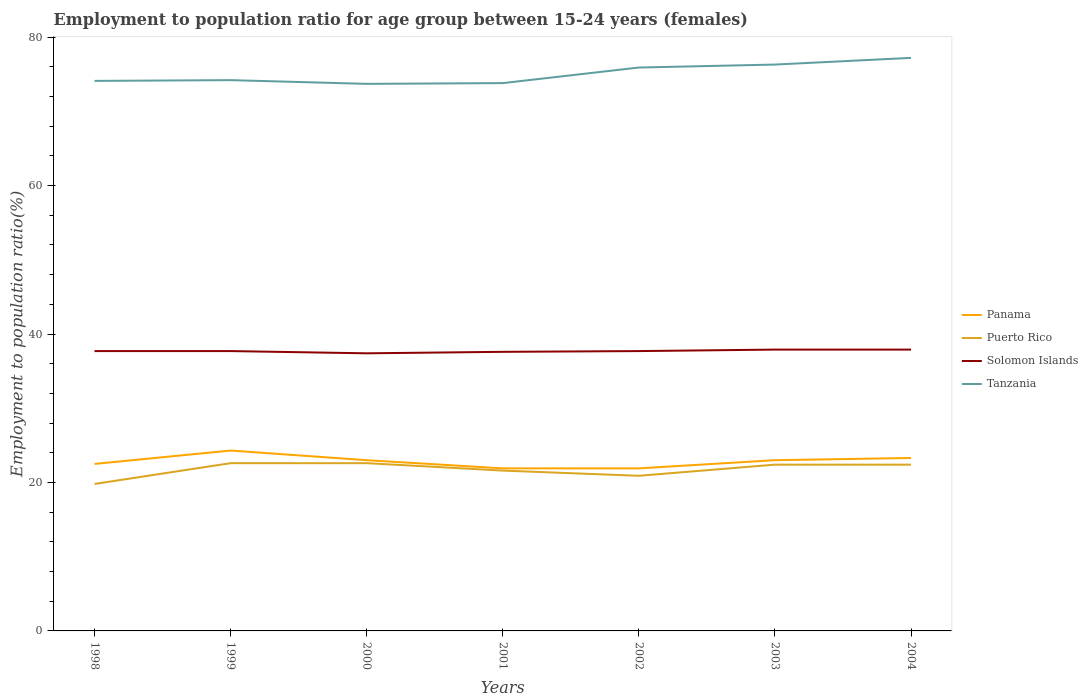Is the number of lines equal to the number of legend labels?
Ensure brevity in your answer.  Yes. Across all years, what is the maximum employment to population ratio in Panama?
Ensure brevity in your answer.  21.9. In which year was the employment to population ratio in Panama maximum?
Make the answer very short. 2001. What is the total employment to population ratio in Tanzania in the graph?
Your response must be concise. 0.4. What is the difference between the highest and the second highest employment to population ratio in Puerto Rico?
Offer a terse response. 2.8. What is the difference between the highest and the lowest employment to population ratio in Tanzania?
Provide a succinct answer. 3. Is the employment to population ratio in Panama strictly greater than the employment to population ratio in Solomon Islands over the years?
Your response must be concise. Yes. How many lines are there?
Make the answer very short. 4. How many years are there in the graph?
Offer a very short reply. 7. What is the difference between two consecutive major ticks on the Y-axis?
Make the answer very short. 20. Does the graph contain any zero values?
Provide a short and direct response. No. Does the graph contain grids?
Provide a succinct answer. No. Where does the legend appear in the graph?
Offer a terse response. Center right. How many legend labels are there?
Give a very brief answer. 4. What is the title of the graph?
Make the answer very short. Employment to population ratio for age group between 15-24 years (females). What is the Employment to population ratio(%) of Panama in 1998?
Your answer should be very brief. 22.5. What is the Employment to population ratio(%) of Puerto Rico in 1998?
Your answer should be very brief. 19.8. What is the Employment to population ratio(%) in Solomon Islands in 1998?
Your answer should be very brief. 37.7. What is the Employment to population ratio(%) of Tanzania in 1998?
Provide a succinct answer. 74.1. What is the Employment to population ratio(%) in Panama in 1999?
Your response must be concise. 24.3. What is the Employment to population ratio(%) in Puerto Rico in 1999?
Keep it short and to the point. 22.6. What is the Employment to population ratio(%) in Solomon Islands in 1999?
Keep it short and to the point. 37.7. What is the Employment to population ratio(%) in Tanzania in 1999?
Your response must be concise. 74.2. What is the Employment to population ratio(%) of Puerto Rico in 2000?
Keep it short and to the point. 22.6. What is the Employment to population ratio(%) of Solomon Islands in 2000?
Ensure brevity in your answer.  37.4. What is the Employment to population ratio(%) of Tanzania in 2000?
Ensure brevity in your answer.  73.7. What is the Employment to population ratio(%) of Panama in 2001?
Your response must be concise. 21.9. What is the Employment to population ratio(%) in Puerto Rico in 2001?
Provide a short and direct response. 21.6. What is the Employment to population ratio(%) of Solomon Islands in 2001?
Your answer should be very brief. 37.6. What is the Employment to population ratio(%) in Tanzania in 2001?
Provide a succinct answer. 73.8. What is the Employment to population ratio(%) of Panama in 2002?
Offer a very short reply. 21.9. What is the Employment to population ratio(%) in Puerto Rico in 2002?
Offer a very short reply. 20.9. What is the Employment to population ratio(%) in Solomon Islands in 2002?
Ensure brevity in your answer.  37.7. What is the Employment to population ratio(%) in Tanzania in 2002?
Give a very brief answer. 75.9. What is the Employment to population ratio(%) in Panama in 2003?
Your answer should be compact. 23. What is the Employment to population ratio(%) in Puerto Rico in 2003?
Give a very brief answer. 22.4. What is the Employment to population ratio(%) in Solomon Islands in 2003?
Provide a short and direct response. 37.9. What is the Employment to population ratio(%) in Tanzania in 2003?
Your answer should be compact. 76.3. What is the Employment to population ratio(%) in Panama in 2004?
Give a very brief answer. 23.3. What is the Employment to population ratio(%) of Puerto Rico in 2004?
Ensure brevity in your answer.  22.4. What is the Employment to population ratio(%) in Solomon Islands in 2004?
Your response must be concise. 37.9. What is the Employment to population ratio(%) in Tanzania in 2004?
Provide a short and direct response. 77.2. Across all years, what is the maximum Employment to population ratio(%) in Panama?
Your response must be concise. 24.3. Across all years, what is the maximum Employment to population ratio(%) in Puerto Rico?
Provide a succinct answer. 22.6. Across all years, what is the maximum Employment to population ratio(%) in Solomon Islands?
Offer a very short reply. 37.9. Across all years, what is the maximum Employment to population ratio(%) of Tanzania?
Your answer should be compact. 77.2. Across all years, what is the minimum Employment to population ratio(%) of Panama?
Provide a short and direct response. 21.9. Across all years, what is the minimum Employment to population ratio(%) of Puerto Rico?
Ensure brevity in your answer.  19.8. Across all years, what is the minimum Employment to population ratio(%) of Solomon Islands?
Make the answer very short. 37.4. Across all years, what is the minimum Employment to population ratio(%) in Tanzania?
Ensure brevity in your answer.  73.7. What is the total Employment to population ratio(%) of Panama in the graph?
Provide a short and direct response. 159.9. What is the total Employment to population ratio(%) in Puerto Rico in the graph?
Provide a short and direct response. 152.3. What is the total Employment to population ratio(%) of Solomon Islands in the graph?
Your answer should be very brief. 263.9. What is the total Employment to population ratio(%) in Tanzania in the graph?
Make the answer very short. 525.2. What is the difference between the Employment to population ratio(%) of Panama in 1998 and that in 1999?
Provide a succinct answer. -1.8. What is the difference between the Employment to population ratio(%) of Puerto Rico in 1998 and that in 1999?
Make the answer very short. -2.8. What is the difference between the Employment to population ratio(%) of Solomon Islands in 1998 and that in 1999?
Make the answer very short. 0. What is the difference between the Employment to population ratio(%) in Panama in 1998 and that in 2000?
Make the answer very short. -0.5. What is the difference between the Employment to population ratio(%) of Puerto Rico in 1998 and that in 2000?
Your answer should be very brief. -2.8. What is the difference between the Employment to population ratio(%) of Solomon Islands in 1998 and that in 2002?
Your answer should be compact. 0. What is the difference between the Employment to population ratio(%) in Puerto Rico in 1998 and that in 2003?
Offer a terse response. -2.6. What is the difference between the Employment to population ratio(%) of Puerto Rico in 1998 and that in 2004?
Your response must be concise. -2.6. What is the difference between the Employment to population ratio(%) in Solomon Islands in 1998 and that in 2004?
Your response must be concise. -0.2. What is the difference between the Employment to population ratio(%) in Tanzania in 1998 and that in 2004?
Offer a very short reply. -3.1. What is the difference between the Employment to population ratio(%) of Panama in 1999 and that in 2000?
Make the answer very short. 1.3. What is the difference between the Employment to population ratio(%) in Puerto Rico in 1999 and that in 2000?
Provide a succinct answer. 0. What is the difference between the Employment to population ratio(%) of Tanzania in 1999 and that in 2000?
Keep it short and to the point. 0.5. What is the difference between the Employment to population ratio(%) in Tanzania in 1999 and that in 2001?
Your answer should be very brief. 0.4. What is the difference between the Employment to population ratio(%) of Panama in 1999 and that in 2002?
Your answer should be compact. 2.4. What is the difference between the Employment to population ratio(%) of Tanzania in 1999 and that in 2002?
Keep it short and to the point. -1.7. What is the difference between the Employment to population ratio(%) in Panama in 1999 and that in 2003?
Provide a succinct answer. 1.3. What is the difference between the Employment to population ratio(%) in Puerto Rico in 1999 and that in 2003?
Offer a terse response. 0.2. What is the difference between the Employment to population ratio(%) in Panama in 1999 and that in 2004?
Your answer should be compact. 1. What is the difference between the Employment to population ratio(%) in Solomon Islands in 1999 and that in 2004?
Your answer should be compact. -0.2. What is the difference between the Employment to population ratio(%) of Solomon Islands in 2000 and that in 2001?
Keep it short and to the point. -0.2. What is the difference between the Employment to population ratio(%) in Panama in 2000 and that in 2002?
Your answer should be compact. 1.1. What is the difference between the Employment to population ratio(%) in Puerto Rico in 2000 and that in 2002?
Offer a terse response. 1.7. What is the difference between the Employment to population ratio(%) of Tanzania in 2000 and that in 2002?
Provide a succinct answer. -2.2. What is the difference between the Employment to population ratio(%) of Puerto Rico in 2000 and that in 2003?
Your response must be concise. 0.2. What is the difference between the Employment to population ratio(%) in Solomon Islands in 2000 and that in 2004?
Provide a succinct answer. -0.5. What is the difference between the Employment to population ratio(%) of Tanzania in 2000 and that in 2004?
Offer a terse response. -3.5. What is the difference between the Employment to population ratio(%) in Panama in 2001 and that in 2002?
Give a very brief answer. 0. What is the difference between the Employment to population ratio(%) of Panama in 2001 and that in 2003?
Your answer should be compact. -1.1. What is the difference between the Employment to population ratio(%) of Puerto Rico in 2001 and that in 2003?
Offer a very short reply. -0.8. What is the difference between the Employment to population ratio(%) of Panama in 2001 and that in 2004?
Give a very brief answer. -1.4. What is the difference between the Employment to population ratio(%) in Puerto Rico in 2001 and that in 2004?
Offer a very short reply. -0.8. What is the difference between the Employment to population ratio(%) of Tanzania in 2001 and that in 2004?
Your answer should be very brief. -3.4. What is the difference between the Employment to population ratio(%) in Panama in 2002 and that in 2003?
Keep it short and to the point. -1.1. What is the difference between the Employment to population ratio(%) of Solomon Islands in 2002 and that in 2004?
Give a very brief answer. -0.2. What is the difference between the Employment to population ratio(%) of Tanzania in 2002 and that in 2004?
Ensure brevity in your answer.  -1.3. What is the difference between the Employment to population ratio(%) in Tanzania in 2003 and that in 2004?
Provide a short and direct response. -0.9. What is the difference between the Employment to population ratio(%) of Panama in 1998 and the Employment to population ratio(%) of Puerto Rico in 1999?
Give a very brief answer. -0.1. What is the difference between the Employment to population ratio(%) of Panama in 1998 and the Employment to population ratio(%) of Solomon Islands in 1999?
Offer a very short reply. -15.2. What is the difference between the Employment to population ratio(%) in Panama in 1998 and the Employment to population ratio(%) in Tanzania in 1999?
Keep it short and to the point. -51.7. What is the difference between the Employment to population ratio(%) of Puerto Rico in 1998 and the Employment to population ratio(%) of Solomon Islands in 1999?
Provide a succinct answer. -17.9. What is the difference between the Employment to population ratio(%) in Puerto Rico in 1998 and the Employment to population ratio(%) in Tanzania in 1999?
Provide a succinct answer. -54.4. What is the difference between the Employment to population ratio(%) of Solomon Islands in 1998 and the Employment to population ratio(%) of Tanzania in 1999?
Make the answer very short. -36.5. What is the difference between the Employment to population ratio(%) of Panama in 1998 and the Employment to population ratio(%) of Puerto Rico in 2000?
Provide a short and direct response. -0.1. What is the difference between the Employment to population ratio(%) in Panama in 1998 and the Employment to population ratio(%) in Solomon Islands in 2000?
Your response must be concise. -14.9. What is the difference between the Employment to population ratio(%) in Panama in 1998 and the Employment to population ratio(%) in Tanzania in 2000?
Ensure brevity in your answer.  -51.2. What is the difference between the Employment to population ratio(%) in Puerto Rico in 1998 and the Employment to population ratio(%) in Solomon Islands in 2000?
Your response must be concise. -17.6. What is the difference between the Employment to population ratio(%) of Puerto Rico in 1998 and the Employment to population ratio(%) of Tanzania in 2000?
Your answer should be compact. -53.9. What is the difference between the Employment to population ratio(%) of Solomon Islands in 1998 and the Employment to population ratio(%) of Tanzania in 2000?
Your response must be concise. -36. What is the difference between the Employment to population ratio(%) in Panama in 1998 and the Employment to population ratio(%) in Puerto Rico in 2001?
Offer a terse response. 0.9. What is the difference between the Employment to population ratio(%) in Panama in 1998 and the Employment to population ratio(%) in Solomon Islands in 2001?
Your answer should be compact. -15.1. What is the difference between the Employment to population ratio(%) of Panama in 1998 and the Employment to population ratio(%) of Tanzania in 2001?
Ensure brevity in your answer.  -51.3. What is the difference between the Employment to population ratio(%) in Puerto Rico in 1998 and the Employment to population ratio(%) in Solomon Islands in 2001?
Provide a short and direct response. -17.8. What is the difference between the Employment to population ratio(%) in Puerto Rico in 1998 and the Employment to population ratio(%) in Tanzania in 2001?
Ensure brevity in your answer.  -54. What is the difference between the Employment to population ratio(%) of Solomon Islands in 1998 and the Employment to population ratio(%) of Tanzania in 2001?
Your response must be concise. -36.1. What is the difference between the Employment to population ratio(%) in Panama in 1998 and the Employment to population ratio(%) in Solomon Islands in 2002?
Offer a terse response. -15.2. What is the difference between the Employment to population ratio(%) in Panama in 1998 and the Employment to population ratio(%) in Tanzania in 2002?
Keep it short and to the point. -53.4. What is the difference between the Employment to population ratio(%) in Puerto Rico in 1998 and the Employment to population ratio(%) in Solomon Islands in 2002?
Offer a very short reply. -17.9. What is the difference between the Employment to population ratio(%) of Puerto Rico in 1998 and the Employment to population ratio(%) of Tanzania in 2002?
Offer a very short reply. -56.1. What is the difference between the Employment to population ratio(%) of Solomon Islands in 1998 and the Employment to population ratio(%) of Tanzania in 2002?
Make the answer very short. -38.2. What is the difference between the Employment to population ratio(%) in Panama in 1998 and the Employment to population ratio(%) in Puerto Rico in 2003?
Your response must be concise. 0.1. What is the difference between the Employment to population ratio(%) in Panama in 1998 and the Employment to population ratio(%) in Solomon Islands in 2003?
Offer a terse response. -15.4. What is the difference between the Employment to population ratio(%) in Panama in 1998 and the Employment to population ratio(%) in Tanzania in 2003?
Provide a succinct answer. -53.8. What is the difference between the Employment to population ratio(%) of Puerto Rico in 1998 and the Employment to population ratio(%) of Solomon Islands in 2003?
Offer a terse response. -18.1. What is the difference between the Employment to population ratio(%) of Puerto Rico in 1998 and the Employment to population ratio(%) of Tanzania in 2003?
Offer a very short reply. -56.5. What is the difference between the Employment to population ratio(%) of Solomon Islands in 1998 and the Employment to population ratio(%) of Tanzania in 2003?
Provide a short and direct response. -38.6. What is the difference between the Employment to population ratio(%) in Panama in 1998 and the Employment to population ratio(%) in Solomon Islands in 2004?
Make the answer very short. -15.4. What is the difference between the Employment to population ratio(%) in Panama in 1998 and the Employment to population ratio(%) in Tanzania in 2004?
Ensure brevity in your answer.  -54.7. What is the difference between the Employment to population ratio(%) of Puerto Rico in 1998 and the Employment to population ratio(%) of Solomon Islands in 2004?
Make the answer very short. -18.1. What is the difference between the Employment to population ratio(%) of Puerto Rico in 1998 and the Employment to population ratio(%) of Tanzania in 2004?
Give a very brief answer. -57.4. What is the difference between the Employment to population ratio(%) of Solomon Islands in 1998 and the Employment to population ratio(%) of Tanzania in 2004?
Provide a succinct answer. -39.5. What is the difference between the Employment to population ratio(%) of Panama in 1999 and the Employment to population ratio(%) of Tanzania in 2000?
Offer a terse response. -49.4. What is the difference between the Employment to population ratio(%) of Puerto Rico in 1999 and the Employment to population ratio(%) of Solomon Islands in 2000?
Give a very brief answer. -14.8. What is the difference between the Employment to population ratio(%) of Puerto Rico in 1999 and the Employment to population ratio(%) of Tanzania in 2000?
Offer a terse response. -51.1. What is the difference between the Employment to population ratio(%) of Solomon Islands in 1999 and the Employment to population ratio(%) of Tanzania in 2000?
Keep it short and to the point. -36. What is the difference between the Employment to population ratio(%) in Panama in 1999 and the Employment to population ratio(%) in Tanzania in 2001?
Your answer should be compact. -49.5. What is the difference between the Employment to population ratio(%) in Puerto Rico in 1999 and the Employment to population ratio(%) in Solomon Islands in 2001?
Keep it short and to the point. -15. What is the difference between the Employment to population ratio(%) of Puerto Rico in 1999 and the Employment to population ratio(%) of Tanzania in 2001?
Provide a succinct answer. -51.2. What is the difference between the Employment to population ratio(%) in Solomon Islands in 1999 and the Employment to population ratio(%) in Tanzania in 2001?
Your answer should be compact. -36.1. What is the difference between the Employment to population ratio(%) in Panama in 1999 and the Employment to population ratio(%) in Solomon Islands in 2002?
Ensure brevity in your answer.  -13.4. What is the difference between the Employment to population ratio(%) in Panama in 1999 and the Employment to population ratio(%) in Tanzania in 2002?
Offer a very short reply. -51.6. What is the difference between the Employment to population ratio(%) of Puerto Rico in 1999 and the Employment to population ratio(%) of Solomon Islands in 2002?
Your answer should be compact. -15.1. What is the difference between the Employment to population ratio(%) of Puerto Rico in 1999 and the Employment to population ratio(%) of Tanzania in 2002?
Keep it short and to the point. -53.3. What is the difference between the Employment to population ratio(%) of Solomon Islands in 1999 and the Employment to population ratio(%) of Tanzania in 2002?
Provide a succinct answer. -38.2. What is the difference between the Employment to population ratio(%) of Panama in 1999 and the Employment to population ratio(%) of Puerto Rico in 2003?
Give a very brief answer. 1.9. What is the difference between the Employment to population ratio(%) of Panama in 1999 and the Employment to population ratio(%) of Tanzania in 2003?
Your response must be concise. -52. What is the difference between the Employment to population ratio(%) of Puerto Rico in 1999 and the Employment to population ratio(%) of Solomon Islands in 2003?
Provide a short and direct response. -15.3. What is the difference between the Employment to population ratio(%) of Puerto Rico in 1999 and the Employment to population ratio(%) of Tanzania in 2003?
Offer a very short reply. -53.7. What is the difference between the Employment to population ratio(%) of Solomon Islands in 1999 and the Employment to population ratio(%) of Tanzania in 2003?
Your answer should be compact. -38.6. What is the difference between the Employment to population ratio(%) of Panama in 1999 and the Employment to population ratio(%) of Puerto Rico in 2004?
Your answer should be compact. 1.9. What is the difference between the Employment to population ratio(%) in Panama in 1999 and the Employment to population ratio(%) in Solomon Islands in 2004?
Provide a short and direct response. -13.6. What is the difference between the Employment to population ratio(%) in Panama in 1999 and the Employment to population ratio(%) in Tanzania in 2004?
Offer a very short reply. -52.9. What is the difference between the Employment to population ratio(%) of Puerto Rico in 1999 and the Employment to population ratio(%) of Solomon Islands in 2004?
Your answer should be very brief. -15.3. What is the difference between the Employment to population ratio(%) of Puerto Rico in 1999 and the Employment to population ratio(%) of Tanzania in 2004?
Your answer should be compact. -54.6. What is the difference between the Employment to population ratio(%) of Solomon Islands in 1999 and the Employment to population ratio(%) of Tanzania in 2004?
Give a very brief answer. -39.5. What is the difference between the Employment to population ratio(%) in Panama in 2000 and the Employment to population ratio(%) in Puerto Rico in 2001?
Make the answer very short. 1.4. What is the difference between the Employment to population ratio(%) of Panama in 2000 and the Employment to population ratio(%) of Solomon Islands in 2001?
Offer a terse response. -14.6. What is the difference between the Employment to population ratio(%) of Panama in 2000 and the Employment to population ratio(%) of Tanzania in 2001?
Your answer should be compact. -50.8. What is the difference between the Employment to population ratio(%) of Puerto Rico in 2000 and the Employment to population ratio(%) of Solomon Islands in 2001?
Your response must be concise. -15. What is the difference between the Employment to population ratio(%) in Puerto Rico in 2000 and the Employment to population ratio(%) in Tanzania in 2001?
Offer a very short reply. -51.2. What is the difference between the Employment to population ratio(%) in Solomon Islands in 2000 and the Employment to population ratio(%) in Tanzania in 2001?
Keep it short and to the point. -36.4. What is the difference between the Employment to population ratio(%) of Panama in 2000 and the Employment to population ratio(%) of Puerto Rico in 2002?
Keep it short and to the point. 2.1. What is the difference between the Employment to population ratio(%) of Panama in 2000 and the Employment to population ratio(%) of Solomon Islands in 2002?
Give a very brief answer. -14.7. What is the difference between the Employment to population ratio(%) of Panama in 2000 and the Employment to population ratio(%) of Tanzania in 2002?
Provide a succinct answer. -52.9. What is the difference between the Employment to population ratio(%) of Puerto Rico in 2000 and the Employment to population ratio(%) of Solomon Islands in 2002?
Keep it short and to the point. -15.1. What is the difference between the Employment to population ratio(%) in Puerto Rico in 2000 and the Employment to population ratio(%) in Tanzania in 2002?
Provide a short and direct response. -53.3. What is the difference between the Employment to population ratio(%) in Solomon Islands in 2000 and the Employment to population ratio(%) in Tanzania in 2002?
Ensure brevity in your answer.  -38.5. What is the difference between the Employment to population ratio(%) of Panama in 2000 and the Employment to population ratio(%) of Puerto Rico in 2003?
Offer a terse response. 0.6. What is the difference between the Employment to population ratio(%) in Panama in 2000 and the Employment to population ratio(%) in Solomon Islands in 2003?
Make the answer very short. -14.9. What is the difference between the Employment to population ratio(%) in Panama in 2000 and the Employment to population ratio(%) in Tanzania in 2003?
Provide a short and direct response. -53.3. What is the difference between the Employment to population ratio(%) of Puerto Rico in 2000 and the Employment to population ratio(%) of Solomon Islands in 2003?
Make the answer very short. -15.3. What is the difference between the Employment to population ratio(%) in Puerto Rico in 2000 and the Employment to population ratio(%) in Tanzania in 2003?
Make the answer very short. -53.7. What is the difference between the Employment to population ratio(%) of Solomon Islands in 2000 and the Employment to population ratio(%) of Tanzania in 2003?
Offer a terse response. -38.9. What is the difference between the Employment to population ratio(%) in Panama in 2000 and the Employment to population ratio(%) in Solomon Islands in 2004?
Provide a succinct answer. -14.9. What is the difference between the Employment to population ratio(%) of Panama in 2000 and the Employment to population ratio(%) of Tanzania in 2004?
Ensure brevity in your answer.  -54.2. What is the difference between the Employment to population ratio(%) in Puerto Rico in 2000 and the Employment to population ratio(%) in Solomon Islands in 2004?
Your answer should be compact. -15.3. What is the difference between the Employment to population ratio(%) in Puerto Rico in 2000 and the Employment to population ratio(%) in Tanzania in 2004?
Your answer should be very brief. -54.6. What is the difference between the Employment to population ratio(%) of Solomon Islands in 2000 and the Employment to population ratio(%) of Tanzania in 2004?
Make the answer very short. -39.8. What is the difference between the Employment to population ratio(%) in Panama in 2001 and the Employment to population ratio(%) in Solomon Islands in 2002?
Your answer should be compact. -15.8. What is the difference between the Employment to population ratio(%) in Panama in 2001 and the Employment to population ratio(%) in Tanzania in 2002?
Offer a terse response. -54. What is the difference between the Employment to population ratio(%) of Puerto Rico in 2001 and the Employment to population ratio(%) of Solomon Islands in 2002?
Provide a succinct answer. -16.1. What is the difference between the Employment to population ratio(%) in Puerto Rico in 2001 and the Employment to population ratio(%) in Tanzania in 2002?
Give a very brief answer. -54.3. What is the difference between the Employment to population ratio(%) of Solomon Islands in 2001 and the Employment to population ratio(%) of Tanzania in 2002?
Your answer should be compact. -38.3. What is the difference between the Employment to population ratio(%) in Panama in 2001 and the Employment to population ratio(%) in Tanzania in 2003?
Provide a short and direct response. -54.4. What is the difference between the Employment to population ratio(%) in Puerto Rico in 2001 and the Employment to population ratio(%) in Solomon Islands in 2003?
Provide a succinct answer. -16.3. What is the difference between the Employment to population ratio(%) of Puerto Rico in 2001 and the Employment to population ratio(%) of Tanzania in 2003?
Your answer should be very brief. -54.7. What is the difference between the Employment to population ratio(%) in Solomon Islands in 2001 and the Employment to population ratio(%) in Tanzania in 2003?
Offer a very short reply. -38.7. What is the difference between the Employment to population ratio(%) of Panama in 2001 and the Employment to population ratio(%) of Tanzania in 2004?
Give a very brief answer. -55.3. What is the difference between the Employment to population ratio(%) in Puerto Rico in 2001 and the Employment to population ratio(%) in Solomon Islands in 2004?
Keep it short and to the point. -16.3. What is the difference between the Employment to population ratio(%) of Puerto Rico in 2001 and the Employment to population ratio(%) of Tanzania in 2004?
Offer a terse response. -55.6. What is the difference between the Employment to population ratio(%) in Solomon Islands in 2001 and the Employment to population ratio(%) in Tanzania in 2004?
Give a very brief answer. -39.6. What is the difference between the Employment to population ratio(%) in Panama in 2002 and the Employment to population ratio(%) in Tanzania in 2003?
Provide a short and direct response. -54.4. What is the difference between the Employment to population ratio(%) of Puerto Rico in 2002 and the Employment to population ratio(%) of Solomon Islands in 2003?
Your response must be concise. -17. What is the difference between the Employment to population ratio(%) in Puerto Rico in 2002 and the Employment to population ratio(%) in Tanzania in 2003?
Offer a terse response. -55.4. What is the difference between the Employment to population ratio(%) of Solomon Islands in 2002 and the Employment to population ratio(%) of Tanzania in 2003?
Provide a short and direct response. -38.6. What is the difference between the Employment to population ratio(%) in Panama in 2002 and the Employment to population ratio(%) in Puerto Rico in 2004?
Your response must be concise. -0.5. What is the difference between the Employment to population ratio(%) in Panama in 2002 and the Employment to population ratio(%) in Tanzania in 2004?
Your response must be concise. -55.3. What is the difference between the Employment to population ratio(%) of Puerto Rico in 2002 and the Employment to population ratio(%) of Solomon Islands in 2004?
Offer a terse response. -17. What is the difference between the Employment to population ratio(%) in Puerto Rico in 2002 and the Employment to population ratio(%) in Tanzania in 2004?
Your answer should be compact. -56.3. What is the difference between the Employment to population ratio(%) in Solomon Islands in 2002 and the Employment to population ratio(%) in Tanzania in 2004?
Ensure brevity in your answer.  -39.5. What is the difference between the Employment to population ratio(%) of Panama in 2003 and the Employment to population ratio(%) of Solomon Islands in 2004?
Provide a succinct answer. -14.9. What is the difference between the Employment to population ratio(%) of Panama in 2003 and the Employment to population ratio(%) of Tanzania in 2004?
Make the answer very short. -54.2. What is the difference between the Employment to population ratio(%) in Puerto Rico in 2003 and the Employment to population ratio(%) in Solomon Islands in 2004?
Your answer should be very brief. -15.5. What is the difference between the Employment to population ratio(%) in Puerto Rico in 2003 and the Employment to population ratio(%) in Tanzania in 2004?
Provide a succinct answer. -54.8. What is the difference between the Employment to population ratio(%) of Solomon Islands in 2003 and the Employment to population ratio(%) of Tanzania in 2004?
Your response must be concise. -39.3. What is the average Employment to population ratio(%) of Panama per year?
Your response must be concise. 22.84. What is the average Employment to population ratio(%) in Puerto Rico per year?
Make the answer very short. 21.76. What is the average Employment to population ratio(%) in Solomon Islands per year?
Provide a succinct answer. 37.7. What is the average Employment to population ratio(%) of Tanzania per year?
Offer a terse response. 75.03. In the year 1998, what is the difference between the Employment to population ratio(%) in Panama and Employment to population ratio(%) in Solomon Islands?
Ensure brevity in your answer.  -15.2. In the year 1998, what is the difference between the Employment to population ratio(%) in Panama and Employment to population ratio(%) in Tanzania?
Make the answer very short. -51.6. In the year 1998, what is the difference between the Employment to population ratio(%) of Puerto Rico and Employment to population ratio(%) of Solomon Islands?
Ensure brevity in your answer.  -17.9. In the year 1998, what is the difference between the Employment to population ratio(%) in Puerto Rico and Employment to population ratio(%) in Tanzania?
Your answer should be very brief. -54.3. In the year 1998, what is the difference between the Employment to population ratio(%) of Solomon Islands and Employment to population ratio(%) of Tanzania?
Provide a succinct answer. -36.4. In the year 1999, what is the difference between the Employment to population ratio(%) of Panama and Employment to population ratio(%) of Puerto Rico?
Keep it short and to the point. 1.7. In the year 1999, what is the difference between the Employment to population ratio(%) in Panama and Employment to population ratio(%) in Solomon Islands?
Provide a succinct answer. -13.4. In the year 1999, what is the difference between the Employment to population ratio(%) in Panama and Employment to population ratio(%) in Tanzania?
Make the answer very short. -49.9. In the year 1999, what is the difference between the Employment to population ratio(%) of Puerto Rico and Employment to population ratio(%) of Solomon Islands?
Provide a succinct answer. -15.1. In the year 1999, what is the difference between the Employment to population ratio(%) of Puerto Rico and Employment to population ratio(%) of Tanzania?
Your answer should be very brief. -51.6. In the year 1999, what is the difference between the Employment to population ratio(%) of Solomon Islands and Employment to population ratio(%) of Tanzania?
Give a very brief answer. -36.5. In the year 2000, what is the difference between the Employment to population ratio(%) of Panama and Employment to population ratio(%) of Solomon Islands?
Provide a succinct answer. -14.4. In the year 2000, what is the difference between the Employment to population ratio(%) in Panama and Employment to population ratio(%) in Tanzania?
Keep it short and to the point. -50.7. In the year 2000, what is the difference between the Employment to population ratio(%) of Puerto Rico and Employment to population ratio(%) of Solomon Islands?
Make the answer very short. -14.8. In the year 2000, what is the difference between the Employment to population ratio(%) in Puerto Rico and Employment to population ratio(%) in Tanzania?
Provide a short and direct response. -51.1. In the year 2000, what is the difference between the Employment to population ratio(%) of Solomon Islands and Employment to population ratio(%) of Tanzania?
Offer a very short reply. -36.3. In the year 2001, what is the difference between the Employment to population ratio(%) of Panama and Employment to population ratio(%) of Solomon Islands?
Ensure brevity in your answer.  -15.7. In the year 2001, what is the difference between the Employment to population ratio(%) of Panama and Employment to population ratio(%) of Tanzania?
Your answer should be compact. -51.9. In the year 2001, what is the difference between the Employment to population ratio(%) of Puerto Rico and Employment to population ratio(%) of Solomon Islands?
Your answer should be very brief. -16. In the year 2001, what is the difference between the Employment to population ratio(%) of Puerto Rico and Employment to population ratio(%) of Tanzania?
Give a very brief answer. -52.2. In the year 2001, what is the difference between the Employment to population ratio(%) of Solomon Islands and Employment to population ratio(%) of Tanzania?
Keep it short and to the point. -36.2. In the year 2002, what is the difference between the Employment to population ratio(%) of Panama and Employment to population ratio(%) of Solomon Islands?
Offer a terse response. -15.8. In the year 2002, what is the difference between the Employment to population ratio(%) of Panama and Employment to population ratio(%) of Tanzania?
Provide a short and direct response. -54. In the year 2002, what is the difference between the Employment to population ratio(%) in Puerto Rico and Employment to population ratio(%) in Solomon Islands?
Your response must be concise. -16.8. In the year 2002, what is the difference between the Employment to population ratio(%) of Puerto Rico and Employment to population ratio(%) of Tanzania?
Offer a very short reply. -55. In the year 2002, what is the difference between the Employment to population ratio(%) of Solomon Islands and Employment to population ratio(%) of Tanzania?
Give a very brief answer. -38.2. In the year 2003, what is the difference between the Employment to population ratio(%) in Panama and Employment to population ratio(%) in Solomon Islands?
Offer a terse response. -14.9. In the year 2003, what is the difference between the Employment to population ratio(%) in Panama and Employment to population ratio(%) in Tanzania?
Provide a short and direct response. -53.3. In the year 2003, what is the difference between the Employment to population ratio(%) in Puerto Rico and Employment to population ratio(%) in Solomon Islands?
Offer a very short reply. -15.5. In the year 2003, what is the difference between the Employment to population ratio(%) of Puerto Rico and Employment to population ratio(%) of Tanzania?
Give a very brief answer. -53.9. In the year 2003, what is the difference between the Employment to population ratio(%) in Solomon Islands and Employment to population ratio(%) in Tanzania?
Ensure brevity in your answer.  -38.4. In the year 2004, what is the difference between the Employment to population ratio(%) of Panama and Employment to population ratio(%) of Solomon Islands?
Offer a terse response. -14.6. In the year 2004, what is the difference between the Employment to population ratio(%) in Panama and Employment to population ratio(%) in Tanzania?
Offer a very short reply. -53.9. In the year 2004, what is the difference between the Employment to population ratio(%) of Puerto Rico and Employment to population ratio(%) of Solomon Islands?
Your answer should be very brief. -15.5. In the year 2004, what is the difference between the Employment to population ratio(%) in Puerto Rico and Employment to population ratio(%) in Tanzania?
Make the answer very short. -54.8. In the year 2004, what is the difference between the Employment to population ratio(%) of Solomon Islands and Employment to population ratio(%) of Tanzania?
Your answer should be compact. -39.3. What is the ratio of the Employment to population ratio(%) of Panama in 1998 to that in 1999?
Your answer should be very brief. 0.93. What is the ratio of the Employment to population ratio(%) of Puerto Rico in 1998 to that in 1999?
Make the answer very short. 0.88. What is the ratio of the Employment to population ratio(%) of Tanzania in 1998 to that in 1999?
Ensure brevity in your answer.  1. What is the ratio of the Employment to population ratio(%) in Panama in 1998 to that in 2000?
Offer a very short reply. 0.98. What is the ratio of the Employment to population ratio(%) in Puerto Rico in 1998 to that in 2000?
Make the answer very short. 0.88. What is the ratio of the Employment to population ratio(%) of Solomon Islands in 1998 to that in 2000?
Your answer should be very brief. 1.01. What is the ratio of the Employment to population ratio(%) in Tanzania in 1998 to that in 2000?
Keep it short and to the point. 1.01. What is the ratio of the Employment to population ratio(%) in Panama in 1998 to that in 2001?
Keep it short and to the point. 1.03. What is the ratio of the Employment to population ratio(%) in Tanzania in 1998 to that in 2001?
Your response must be concise. 1. What is the ratio of the Employment to population ratio(%) of Panama in 1998 to that in 2002?
Keep it short and to the point. 1.03. What is the ratio of the Employment to population ratio(%) in Puerto Rico in 1998 to that in 2002?
Offer a very short reply. 0.95. What is the ratio of the Employment to population ratio(%) in Tanzania in 1998 to that in 2002?
Offer a very short reply. 0.98. What is the ratio of the Employment to population ratio(%) in Panama in 1998 to that in 2003?
Your answer should be compact. 0.98. What is the ratio of the Employment to population ratio(%) of Puerto Rico in 1998 to that in 2003?
Give a very brief answer. 0.88. What is the ratio of the Employment to population ratio(%) of Solomon Islands in 1998 to that in 2003?
Offer a terse response. 0.99. What is the ratio of the Employment to population ratio(%) of Tanzania in 1998 to that in 2003?
Offer a very short reply. 0.97. What is the ratio of the Employment to population ratio(%) of Panama in 1998 to that in 2004?
Provide a short and direct response. 0.97. What is the ratio of the Employment to population ratio(%) of Puerto Rico in 1998 to that in 2004?
Ensure brevity in your answer.  0.88. What is the ratio of the Employment to population ratio(%) in Tanzania in 1998 to that in 2004?
Your answer should be very brief. 0.96. What is the ratio of the Employment to population ratio(%) of Panama in 1999 to that in 2000?
Offer a very short reply. 1.06. What is the ratio of the Employment to population ratio(%) of Tanzania in 1999 to that in 2000?
Your answer should be compact. 1.01. What is the ratio of the Employment to population ratio(%) in Panama in 1999 to that in 2001?
Offer a very short reply. 1.11. What is the ratio of the Employment to population ratio(%) in Puerto Rico in 1999 to that in 2001?
Give a very brief answer. 1.05. What is the ratio of the Employment to population ratio(%) in Tanzania in 1999 to that in 2001?
Provide a succinct answer. 1.01. What is the ratio of the Employment to population ratio(%) of Panama in 1999 to that in 2002?
Offer a terse response. 1.11. What is the ratio of the Employment to population ratio(%) in Puerto Rico in 1999 to that in 2002?
Keep it short and to the point. 1.08. What is the ratio of the Employment to population ratio(%) of Solomon Islands in 1999 to that in 2002?
Provide a succinct answer. 1. What is the ratio of the Employment to population ratio(%) of Tanzania in 1999 to that in 2002?
Offer a terse response. 0.98. What is the ratio of the Employment to population ratio(%) in Panama in 1999 to that in 2003?
Keep it short and to the point. 1.06. What is the ratio of the Employment to population ratio(%) of Puerto Rico in 1999 to that in 2003?
Make the answer very short. 1.01. What is the ratio of the Employment to population ratio(%) in Tanzania in 1999 to that in 2003?
Ensure brevity in your answer.  0.97. What is the ratio of the Employment to population ratio(%) in Panama in 1999 to that in 2004?
Keep it short and to the point. 1.04. What is the ratio of the Employment to population ratio(%) in Puerto Rico in 1999 to that in 2004?
Make the answer very short. 1.01. What is the ratio of the Employment to population ratio(%) of Solomon Islands in 1999 to that in 2004?
Offer a terse response. 0.99. What is the ratio of the Employment to population ratio(%) of Tanzania in 1999 to that in 2004?
Make the answer very short. 0.96. What is the ratio of the Employment to population ratio(%) in Panama in 2000 to that in 2001?
Offer a terse response. 1.05. What is the ratio of the Employment to population ratio(%) in Puerto Rico in 2000 to that in 2001?
Provide a short and direct response. 1.05. What is the ratio of the Employment to population ratio(%) in Panama in 2000 to that in 2002?
Give a very brief answer. 1.05. What is the ratio of the Employment to population ratio(%) in Puerto Rico in 2000 to that in 2002?
Your response must be concise. 1.08. What is the ratio of the Employment to population ratio(%) in Solomon Islands in 2000 to that in 2002?
Offer a terse response. 0.99. What is the ratio of the Employment to population ratio(%) of Puerto Rico in 2000 to that in 2003?
Your response must be concise. 1.01. What is the ratio of the Employment to population ratio(%) in Tanzania in 2000 to that in 2003?
Give a very brief answer. 0.97. What is the ratio of the Employment to population ratio(%) in Panama in 2000 to that in 2004?
Give a very brief answer. 0.99. What is the ratio of the Employment to population ratio(%) of Puerto Rico in 2000 to that in 2004?
Your answer should be very brief. 1.01. What is the ratio of the Employment to population ratio(%) of Solomon Islands in 2000 to that in 2004?
Offer a terse response. 0.99. What is the ratio of the Employment to population ratio(%) in Tanzania in 2000 to that in 2004?
Your answer should be very brief. 0.95. What is the ratio of the Employment to population ratio(%) of Panama in 2001 to that in 2002?
Provide a short and direct response. 1. What is the ratio of the Employment to population ratio(%) in Puerto Rico in 2001 to that in 2002?
Your answer should be very brief. 1.03. What is the ratio of the Employment to population ratio(%) in Solomon Islands in 2001 to that in 2002?
Offer a terse response. 1. What is the ratio of the Employment to population ratio(%) of Tanzania in 2001 to that in 2002?
Your answer should be very brief. 0.97. What is the ratio of the Employment to population ratio(%) in Panama in 2001 to that in 2003?
Give a very brief answer. 0.95. What is the ratio of the Employment to population ratio(%) of Solomon Islands in 2001 to that in 2003?
Make the answer very short. 0.99. What is the ratio of the Employment to population ratio(%) of Tanzania in 2001 to that in 2003?
Ensure brevity in your answer.  0.97. What is the ratio of the Employment to population ratio(%) of Panama in 2001 to that in 2004?
Your response must be concise. 0.94. What is the ratio of the Employment to population ratio(%) in Puerto Rico in 2001 to that in 2004?
Offer a terse response. 0.96. What is the ratio of the Employment to population ratio(%) in Solomon Islands in 2001 to that in 2004?
Make the answer very short. 0.99. What is the ratio of the Employment to population ratio(%) of Tanzania in 2001 to that in 2004?
Your answer should be very brief. 0.96. What is the ratio of the Employment to population ratio(%) in Panama in 2002 to that in 2003?
Keep it short and to the point. 0.95. What is the ratio of the Employment to population ratio(%) of Puerto Rico in 2002 to that in 2003?
Your answer should be compact. 0.93. What is the ratio of the Employment to population ratio(%) of Solomon Islands in 2002 to that in 2003?
Your response must be concise. 0.99. What is the ratio of the Employment to population ratio(%) in Tanzania in 2002 to that in 2003?
Your response must be concise. 0.99. What is the ratio of the Employment to population ratio(%) in Panama in 2002 to that in 2004?
Your answer should be very brief. 0.94. What is the ratio of the Employment to population ratio(%) of Puerto Rico in 2002 to that in 2004?
Make the answer very short. 0.93. What is the ratio of the Employment to population ratio(%) in Solomon Islands in 2002 to that in 2004?
Offer a very short reply. 0.99. What is the ratio of the Employment to population ratio(%) of Tanzania in 2002 to that in 2004?
Give a very brief answer. 0.98. What is the ratio of the Employment to population ratio(%) in Panama in 2003 to that in 2004?
Your response must be concise. 0.99. What is the ratio of the Employment to population ratio(%) in Solomon Islands in 2003 to that in 2004?
Your answer should be compact. 1. What is the ratio of the Employment to population ratio(%) in Tanzania in 2003 to that in 2004?
Keep it short and to the point. 0.99. What is the difference between the highest and the second highest Employment to population ratio(%) of Puerto Rico?
Offer a terse response. 0. What is the difference between the highest and the second highest Employment to population ratio(%) in Solomon Islands?
Offer a very short reply. 0. What is the difference between the highest and the second highest Employment to population ratio(%) of Tanzania?
Offer a very short reply. 0.9. What is the difference between the highest and the lowest Employment to population ratio(%) of Puerto Rico?
Your response must be concise. 2.8. 